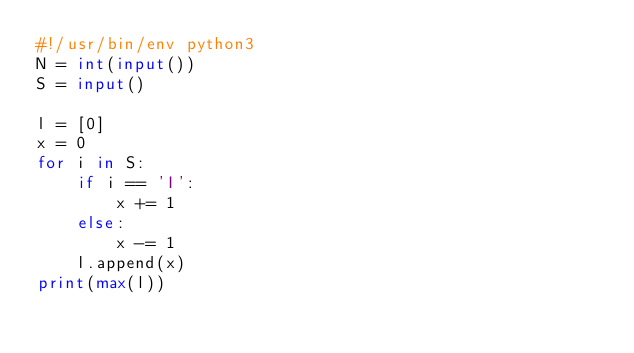Convert code to text. <code><loc_0><loc_0><loc_500><loc_500><_Python_>#!/usr/bin/env python3
N = int(input())
S = input()

l = [0]
x = 0
for i in S:
    if i == 'I':
        x += 1
    else:
        x -= 1
    l.append(x)
print(max(l))
</code> 